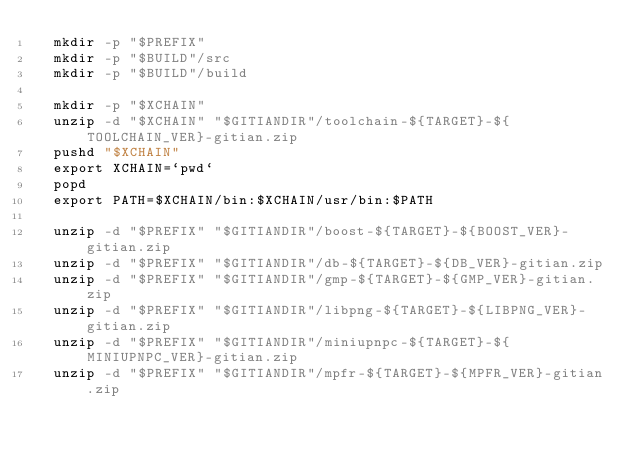<code> <loc_0><loc_0><loc_500><loc_500><_YAML_>  mkdir -p "$PREFIX"
  mkdir -p "$BUILD"/src
  mkdir -p "$BUILD"/build
  
  mkdir -p "$XCHAIN"
  unzip -d "$XCHAIN" "$GITIANDIR"/toolchain-${TARGET}-${TOOLCHAIN_VER}-gitian.zip
  pushd "$XCHAIN"
  export XCHAIN=`pwd`
  popd
  export PATH=$XCHAIN/bin:$XCHAIN/usr/bin:$PATH
  
  unzip -d "$PREFIX" "$GITIANDIR"/boost-${TARGET}-${BOOST_VER}-gitian.zip
  unzip -d "$PREFIX" "$GITIANDIR"/db-${TARGET}-${DB_VER}-gitian.zip
  unzip -d "$PREFIX" "$GITIANDIR"/gmp-${TARGET}-${GMP_VER}-gitian.zip
  unzip -d "$PREFIX" "$GITIANDIR"/libpng-${TARGET}-${LIBPNG_VER}-gitian.zip
  unzip -d "$PREFIX" "$GITIANDIR"/miniupnpc-${TARGET}-${MINIUPNPC_VER}-gitian.zip
  unzip -d "$PREFIX" "$GITIANDIR"/mpfr-${TARGET}-${MPFR_VER}-gitian.zip</code> 